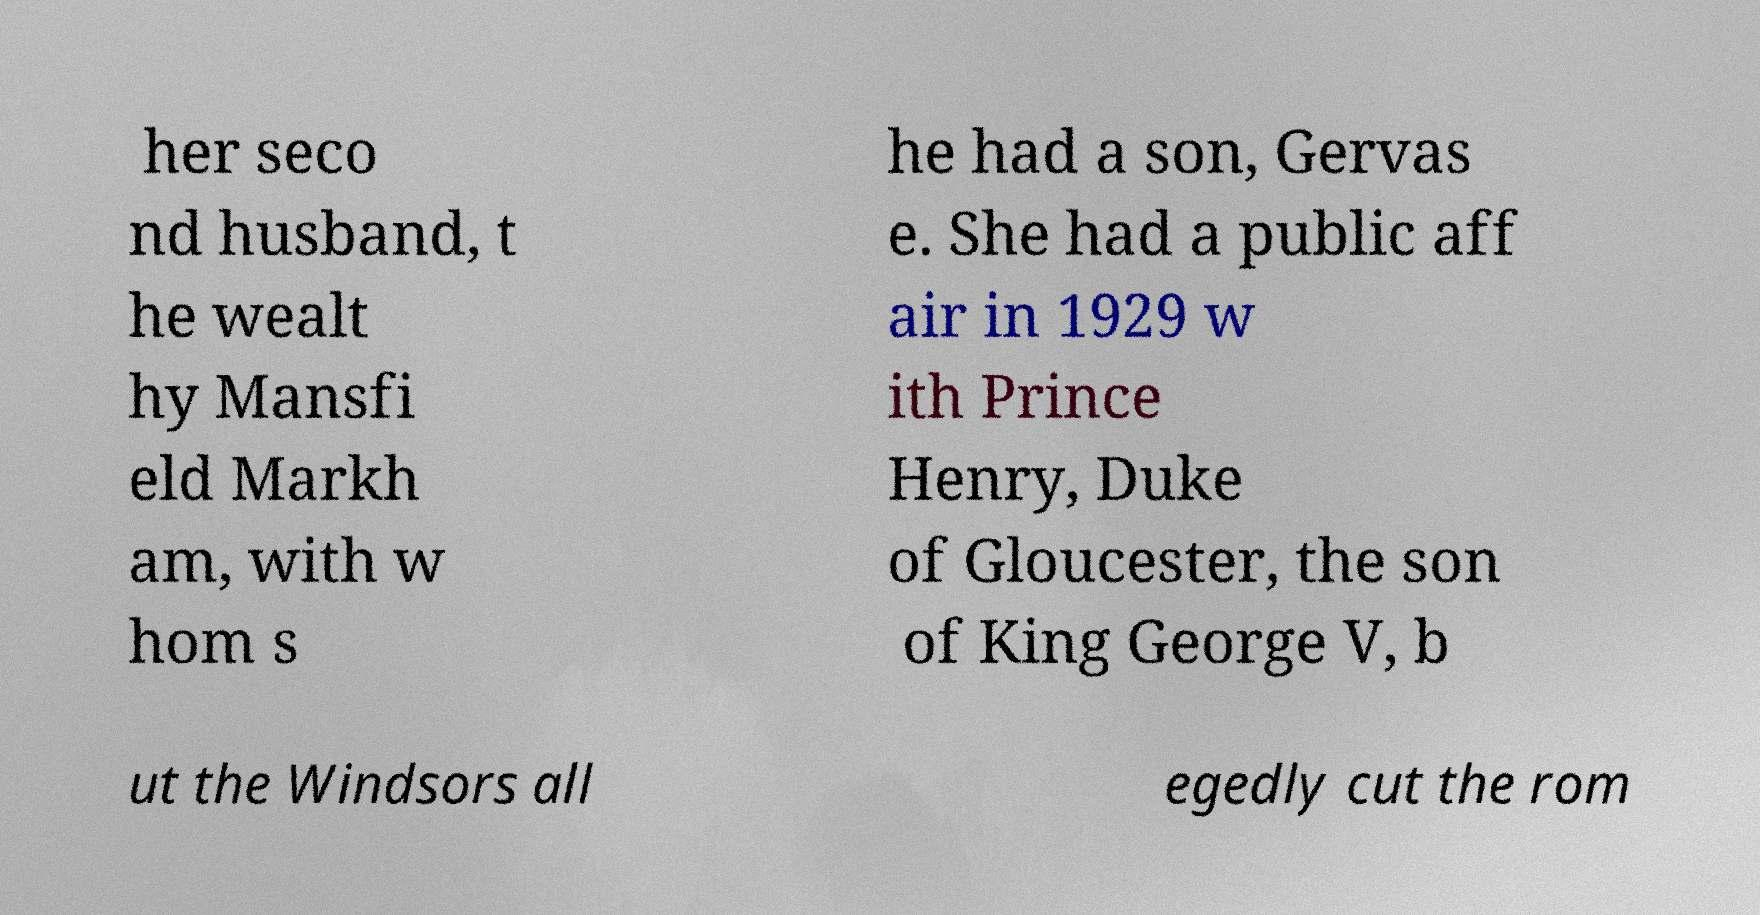Can you accurately transcribe the text from the provided image for me? her seco nd husband, t he wealt hy Mansfi eld Markh am, with w hom s he had a son, Gervas e. She had a public aff air in 1929 w ith Prince Henry, Duke of Gloucester, the son of King George V, b ut the Windsors all egedly cut the rom 